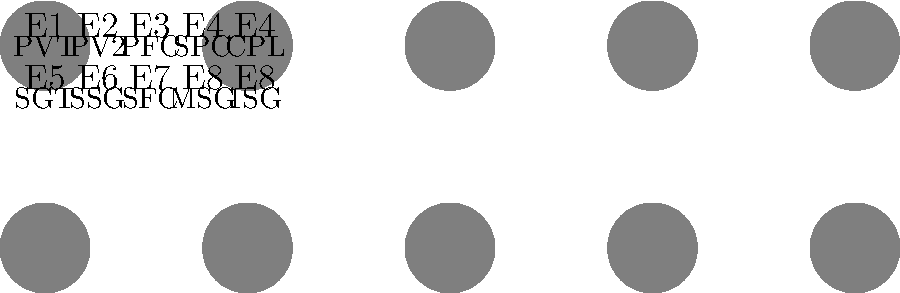Based on the chart of Army enlisted rank insignia, which rank corresponds to the pay grade E7? To answer this question, we need to follow these steps:

1. Examine the chart of Army enlisted rank insignia.
2. Locate the row that contains the E7 pay grade.
3. Identify the rank abbreviation associated with E7.

Looking at the chart:
1. The top row shows ranks from PVT (E1) to CPL (E4).
2. The bottom row shows ranks from SGT (E5) to 1SG (E8).
3. We can see that E7 is in the bottom row, third from the left.
4. The rank abbreviation corresponding to E7 is SFC.

SFC stands for Sergeant First Class, which is the correct rank for pay grade E7 in the U.S. Army.
Answer: SFC (Sergeant First Class) 